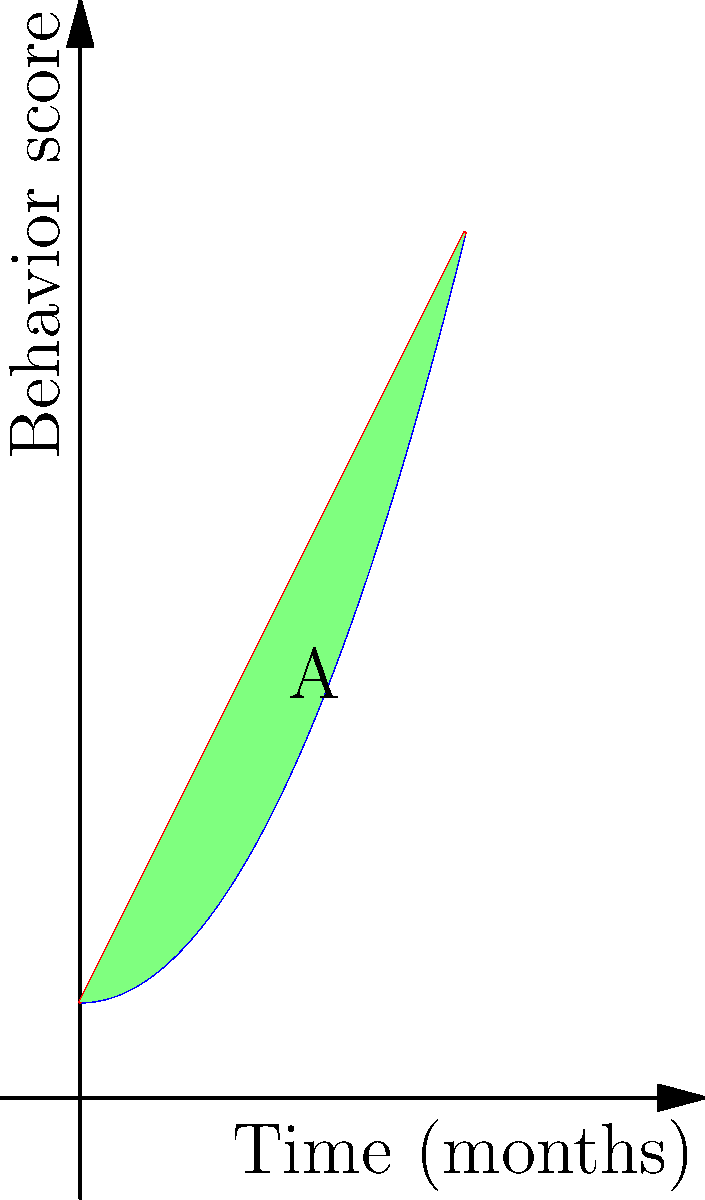A child psychologist is tracking the improvement in a child's behavior over a 4-month period of therapy. The baseline behavior is modeled by the function $f(x) = 0.5x^2 + 1$, and the improved behavior after therapy is modeled by $g(x) = 2x + 1$, where $x$ represents time in months and $y$ represents a behavior score. Calculate the total improvement in the child's behavior over the 4-month period, represented by the area A between the two curves. To find the area between the two curves, we need to integrate the difference between $g(x)$ and $f(x)$ from 0 to 4 months:

1) Set up the integral:
   $$A = \int_0^4 [g(x) - f(x)] dx = \int_0^4 [(2x + 1) - (0.5x^2 + 1)] dx$$

2) Simplify the integrand:
   $$A = \int_0^4 (2x - 0.5x^2) dx$$

3) Integrate:
   $$A = \left[x^2 - \frac{1}{6}x^3\right]_0^4$$

4) Evaluate the definite integral:
   $$A = (4^2 - \frac{1}{6}4^3) - (0^2 - \frac{1}{6}0^3)$$
   $$A = (16 - \frac{64}{6}) - 0$$
   $$A = 16 - \frac{32}{3}$$

5) Simplify:
   $$A = \frac{48}{3} - \frac{32}{3} = \frac{16}{3}$$

Therefore, the total improvement in the child's behavior over the 4-month period is $\frac{16}{3}$ units.
Answer: $\frac{16}{3}$ units 